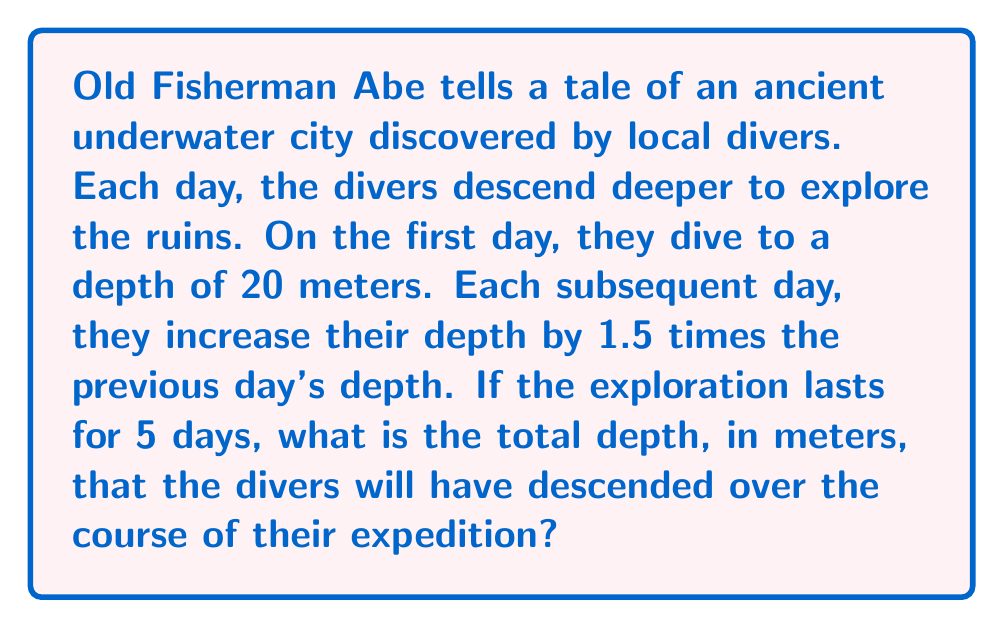Teach me how to tackle this problem. Let's approach this step-by-step using the formula for the sum of a geometric sequence:

1) First, we identify the components of our geometric sequence:
   - First term, $a = 20$ meters
   - Common ratio, $r = 1.5$
   - Number of terms, $n = 5$ days

2) The formula for the sum of a geometric sequence is:
   $$S_n = \frac{a(1-r^n)}{1-r}$$
   where $S_n$ is the sum of the sequence, $a$ is the first term, $r$ is the common ratio, and $n$ is the number of terms.

3) Let's substitute our values:
   $$S_5 = \frac{20(1-1.5^5)}{1-1.5}$$

4) Simplify the numerator:
   $1.5^5 = 7.59375$
   $$S_5 = \frac{20(1-7.59375)}{-0.5}$$

5) Continue simplifying:
   $$S_5 = \frac{20(-6.59375)}{-0.5} = \frac{131.875}{0.5} = 263.75$$

Therefore, the total depth descended over the 5 days is 263.75 meters.
Answer: 263.75 meters 